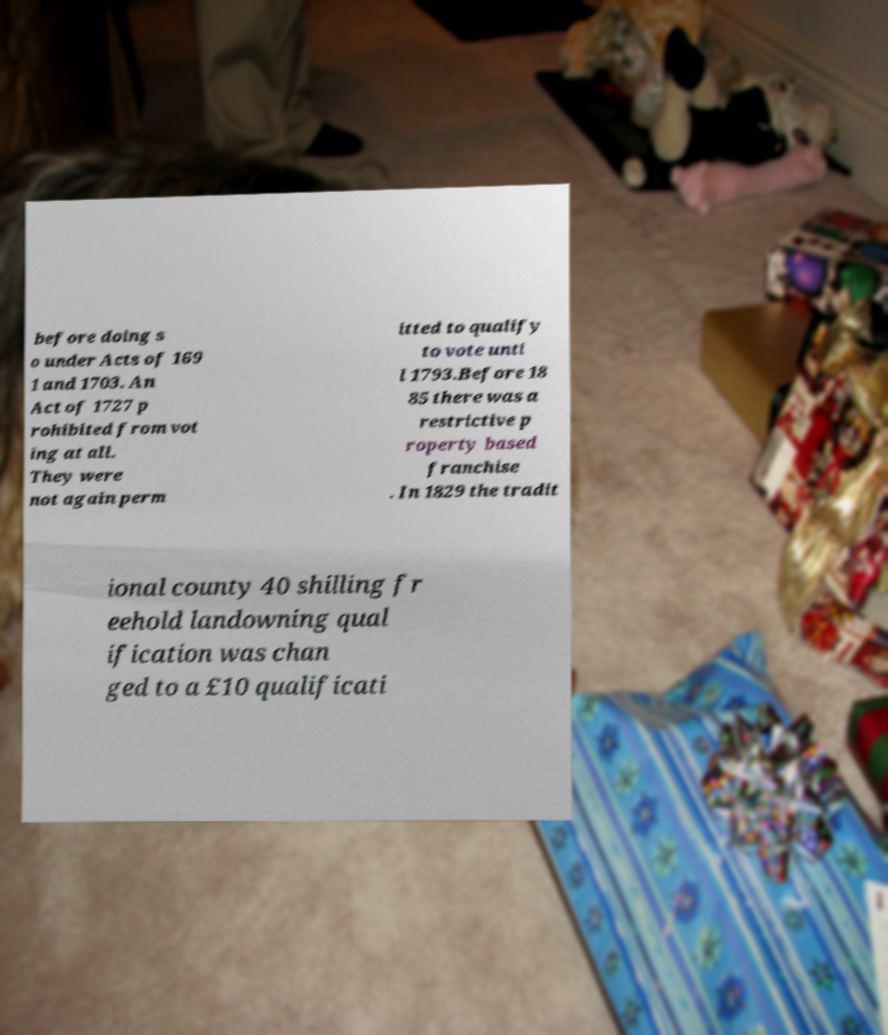For documentation purposes, I need the text within this image transcribed. Could you provide that? before doing s o under Acts of 169 1 and 1703. An Act of 1727 p rohibited from vot ing at all. They were not again perm itted to qualify to vote unti l 1793.Before 18 85 there was a restrictive p roperty based franchise . In 1829 the tradit ional county 40 shilling fr eehold landowning qual ification was chan ged to a £10 qualificati 